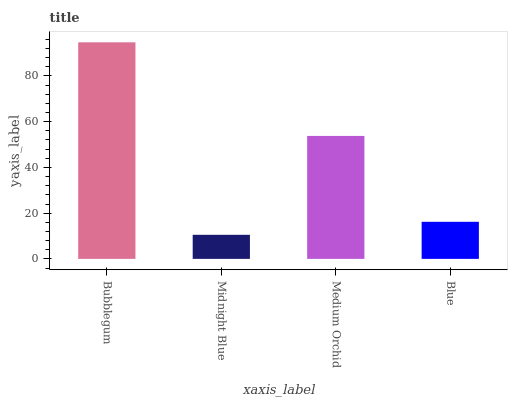Is Midnight Blue the minimum?
Answer yes or no. Yes. Is Bubblegum the maximum?
Answer yes or no. Yes. Is Medium Orchid the minimum?
Answer yes or no. No. Is Medium Orchid the maximum?
Answer yes or no. No. Is Medium Orchid greater than Midnight Blue?
Answer yes or no. Yes. Is Midnight Blue less than Medium Orchid?
Answer yes or no. Yes. Is Midnight Blue greater than Medium Orchid?
Answer yes or no. No. Is Medium Orchid less than Midnight Blue?
Answer yes or no. No. Is Medium Orchid the high median?
Answer yes or no. Yes. Is Blue the low median?
Answer yes or no. Yes. Is Blue the high median?
Answer yes or no. No. Is Medium Orchid the low median?
Answer yes or no. No. 